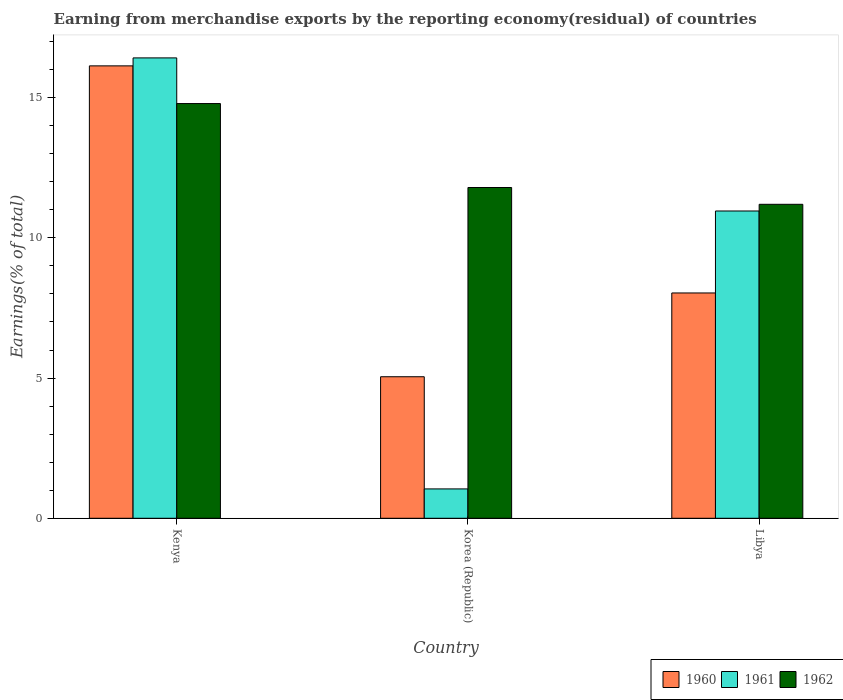How many groups of bars are there?
Provide a succinct answer. 3. How many bars are there on the 1st tick from the left?
Your response must be concise. 3. What is the label of the 1st group of bars from the left?
Provide a short and direct response. Kenya. What is the percentage of amount earned from merchandise exports in 1960 in Libya?
Offer a terse response. 8.04. Across all countries, what is the maximum percentage of amount earned from merchandise exports in 1961?
Keep it short and to the point. 16.42. Across all countries, what is the minimum percentage of amount earned from merchandise exports in 1960?
Your answer should be very brief. 5.05. In which country was the percentage of amount earned from merchandise exports in 1961 maximum?
Your answer should be compact. Kenya. In which country was the percentage of amount earned from merchandise exports in 1960 minimum?
Give a very brief answer. Korea (Republic). What is the total percentage of amount earned from merchandise exports in 1960 in the graph?
Keep it short and to the point. 29.22. What is the difference between the percentage of amount earned from merchandise exports in 1962 in Korea (Republic) and that in Libya?
Offer a terse response. 0.6. What is the difference between the percentage of amount earned from merchandise exports in 1962 in Libya and the percentage of amount earned from merchandise exports in 1961 in Kenya?
Keep it short and to the point. -5.22. What is the average percentage of amount earned from merchandise exports in 1960 per country?
Ensure brevity in your answer.  9.74. What is the difference between the percentage of amount earned from merchandise exports of/in 1961 and percentage of amount earned from merchandise exports of/in 1962 in Korea (Republic)?
Ensure brevity in your answer.  -10.75. What is the ratio of the percentage of amount earned from merchandise exports in 1961 in Kenya to that in Libya?
Offer a terse response. 1.5. Is the difference between the percentage of amount earned from merchandise exports in 1961 in Korea (Republic) and Libya greater than the difference between the percentage of amount earned from merchandise exports in 1962 in Korea (Republic) and Libya?
Ensure brevity in your answer.  No. What is the difference between the highest and the second highest percentage of amount earned from merchandise exports in 1962?
Give a very brief answer. -0.6. What is the difference between the highest and the lowest percentage of amount earned from merchandise exports in 1961?
Provide a short and direct response. 15.37. How many bars are there?
Your answer should be compact. 9. Are all the bars in the graph horizontal?
Offer a very short reply. No. How many countries are there in the graph?
Offer a terse response. 3. Does the graph contain grids?
Your answer should be very brief. No. Where does the legend appear in the graph?
Provide a succinct answer. Bottom right. How many legend labels are there?
Ensure brevity in your answer.  3. How are the legend labels stacked?
Provide a short and direct response. Horizontal. What is the title of the graph?
Ensure brevity in your answer.  Earning from merchandise exports by the reporting economy(residual) of countries. Does "1975" appear as one of the legend labels in the graph?
Your answer should be compact. No. What is the label or title of the X-axis?
Make the answer very short. Country. What is the label or title of the Y-axis?
Your answer should be compact. Earnings(% of total). What is the Earnings(% of total) in 1960 in Kenya?
Your response must be concise. 16.13. What is the Earnings(% of total) of 1961 in Kenya?
Keep it short and to the point. 16.42. What is the Earnings(% of total) in 1962 in Kenya?
Your answer should be very brief. 14.79. What is the Earnings(% of total) in 1960 in Korea (Republic)?
Offer a very short reply. 5.05. What is the Earnings(% of total) in 1961 in Korea (Republic)?
Provide a succinct answer. 1.05. What is the Earnings(% of total) of 1962 in Korea (Republic)?
Your response must be concise. 11.8. What is the Earnings(% of total) of 1960 in Libya?
Make the answer very short. 8.04. What is the Earnings(% of total) of 1961 in Libya?
Ensure brevity in your answer.  10.96. What is the Earnings(% of total) of 1962 in Libya?
Your answer should be compact. 11.2. Across all countries, what is the maximum Earnings(% of total) in 1960?
Give a very brief answer. 16.13. Across all countries, what is the maximum Earnings(% of total) in 1961?
Provide a short and direct response. 16.42. Across all countries, what is the maximum Earnings(% of total) of 1962?
Your answer should be compact. 14.79. Across all countries, what is the minimum Earnings(% of total) of 1960?
Your answer should be compact. 5.05. Across all countries, what is the minimum Earnings(% of total) of 1961?
Ensure brevity in your answer.  1.05. Across all countries, what is the minimum Earnings(% of total) in 1962?
Offer a very short reply. 11.2. What is the total Earnings(% of total) in 1960 in the graph?
Offer a terse response. 29.22. What is the total Earnings(% of total) in 1961 in the graph?
Provide a short and direct response. 28.43. What is the total Earnings(% of total) of 1962 in the graph?
Give a very brief answer. 37.78. What is the difference between the Earnings(% of total) in 1960 in Kenya and that in Korea (Republic)?
Make the answer very short. 11.09. What is the difference between the Earnings(% of total) of 1961 in Kenya and that in Korea (Republic)?
Give a very brief answer. 15.37. What is the difference between the Earnings(% of total) in 1962 in Kenya and that in Korea (Republic)?
Your answer should be compact. 2.99. What is the difference between the Earnings(% of total) of 1960 in Kenya and that in Libya?
Your answer should be very brief. 8.1. What is the difference between the Earnings(% of total) of 1961 in Kenya and that in Libya?
Your answer should be very brief. 5.46. What is the difference between the Earnings(% of total) of 1962 in Kenya and that in Libya?
Provide a short and direct response. 3.59. What is the difference between the Earnings(% of total) in 1960 in Korea (Republic) and that in Libya?
Offer a very short reply. -2.99. What is the difference between the Earnings(% of total) in 1961 in Korea (Republic) and that in Libya?
Provide a short and direct response. -9.91. What is the difference between the Earnings(% of total) in 1962 in Korea (Republic) and that in Libya?
Offer a terse response. 0.6. What is the difference between the Earnings(% of total) in 1960 in Kenya and the Earnings(% of total) in 1961 in Korea (Republic)?
Offer a very short reply. 15.09. What is the difference between the Earnings(% of total) of 1960 in Kenya and the Earnings(% of total) of 1962 in Korea (Republic)?
Offer a very short reply. 4.34. What is the difference between the Earnings(% of total) in 1961 in Kenya and the Earnings(% of total) in 1962 in Korea (Republic)?
Provide a succinct answer. 4.62. What is the difference between the Earnings(% of total) in 1960 in Kenya and the Earnings(% of total) in 1961 in Libya?
Offer a terse response. 5.18. What is the difference between the Earnings(% of total) in 1960 in Kenya and the Earnings(% of total) in 1962 in Libya?
Make the answer very short. 4.94. What is the difference between the Earnings(% of total) in 1961 in Kenya and the Earnings(% of total) in 1962 in Libya?
Give a very brief answer. 5.22. What is the difference between the Earnings(% of total) of 1960 in Korea (Republic) and the Earnings(% of total) of 1961 in Libya?
Offer a very short reply. -5.91. What is the difference between the Earnings(% of total) in 1960 in Korea (Republic) and the Earnings(% of total) in 1962 in Libya?
Ensure brevity in your answer.  -6.15. What is the difference between the Earnings(% of total) in 1961 in Korea (Republic) and the Earnings(% of total) in 1962 in Libya?
Provide a succinct answer. -10.15. What is the average Earnings(% of total) in 1960 per country?
Your response must be concise. 9.74. What is the average Earnings(% of total) in 1961 per country?
Make the answer very short. 9.48. What is the average Earnings(% of total) in 1962 per country?
Provide a short and direct response. 12.6. What is the difference between the Earnings(% of total) of 1960 and Earnings(% of total) of 1961 in Kenya?
Your answer should be compact. -0.28. What is the difference between the Earnings(% of total) in 1960 and Earnings(% of total) in 1962 in Kenya?
Keep it short and to the point. 1.34. What is the difference between the Earnings(% of total) of 1961 and Earnings(% of total) of 1962 in Kenya?
Ensure brevity in your answer.  1.63. What is the difference between the Earnings(% of total) of 1960 and Earnings(% of total) of 1961 in Korea (Republic)?
Ensure brevity in your answer.  4. What is the difference between the Earnings(% of total) in 1960 and Earnings(% of total) in 1962 in Korea (Republic)?
Ensure brevity in your answer.  -6.75. What is the difference between the Earnings(% of total) in 1961 and Earnings(% of total) in 1962 in Korea (Republic)?
Offer a very short reply. -10.75. What is the difference between the Earnings(% of total) in 1960 and Earnings(% of total) in 1961 in Libya?
Provide a succinct answer. -2.92. What is the difference between the Earnings(% of total) of 1960 and Earnings(% of total) of 1962 in Libya?
Provide a succinct answer. -3.16. What is the difference between the Earnings(% of total) of 1961 and Earnings(% of total) of 1962 in Libya?
Your answer should be very brief. -0.24. What is the ratio of the Earnings(% of total) in 1960 in Kenya to that in Korea (Republic)?
Ensure brevity in your answer.  3.2. What is the ratio of the Earnings(% of total) of 1961 in Kenya to that in Korea (Republic)?
Your response must be concise. 15.68. What is the ratio of the Earnings(% of total) in 1962 in Kenya to that in Korea (Republic)?
Your response must be concise. 1.25. What is the ratio of the Earnings(% of total) of 1960 in Kenya to that in Libya?
Your answer should be very brief. 2.01. What is the ratio of the Earnings(% of total) of 1961 in Kenya to that in Libya?
Offer a terse response. 1.5. What is the ratio of the Earnings(% of total) in 1962 in Kenya to that in Libya?
Provide a succinct answer. 1.32. What is the ratio of the Earnings(% of total) of 1960 in Korea (Republic) to that in Libya?
Keep it short and to the point. 0.63. What is the ratio of the Earnings(% of total) of 1961 in Korea (Republic) to that in Libya?
Provide a short and direct response. 0.1. What is the ratio of the Earnings(% of total) of 1962 in Korea (Republic) to that in Libya?
Provide a short and direct response. 1.05. What is the difference between the highest and the second highest Earnings(% of total) of 1960?
Ensure brevity in your answer.  8.1. What is the difference between the highest and the second highest Earnings(% of total) in 1961?
Your answer should be compact. 5.46. What is the difference between the highest and the second highest Earnings(% of total) of 1962?
Keep it short and to the point. 2.99. What is the difference between the highest and the lowest Earnings(% of total) of 1960?
Your response must be concise. 11.09. What is the difference between the highest and the lowest Earnings(% of total) in 1961?
Provide a succinct answer. 15.37. What is the difference between the highest and the lowest Earnings(% of total) of 1962?
Your response must be concise. 3.59. 